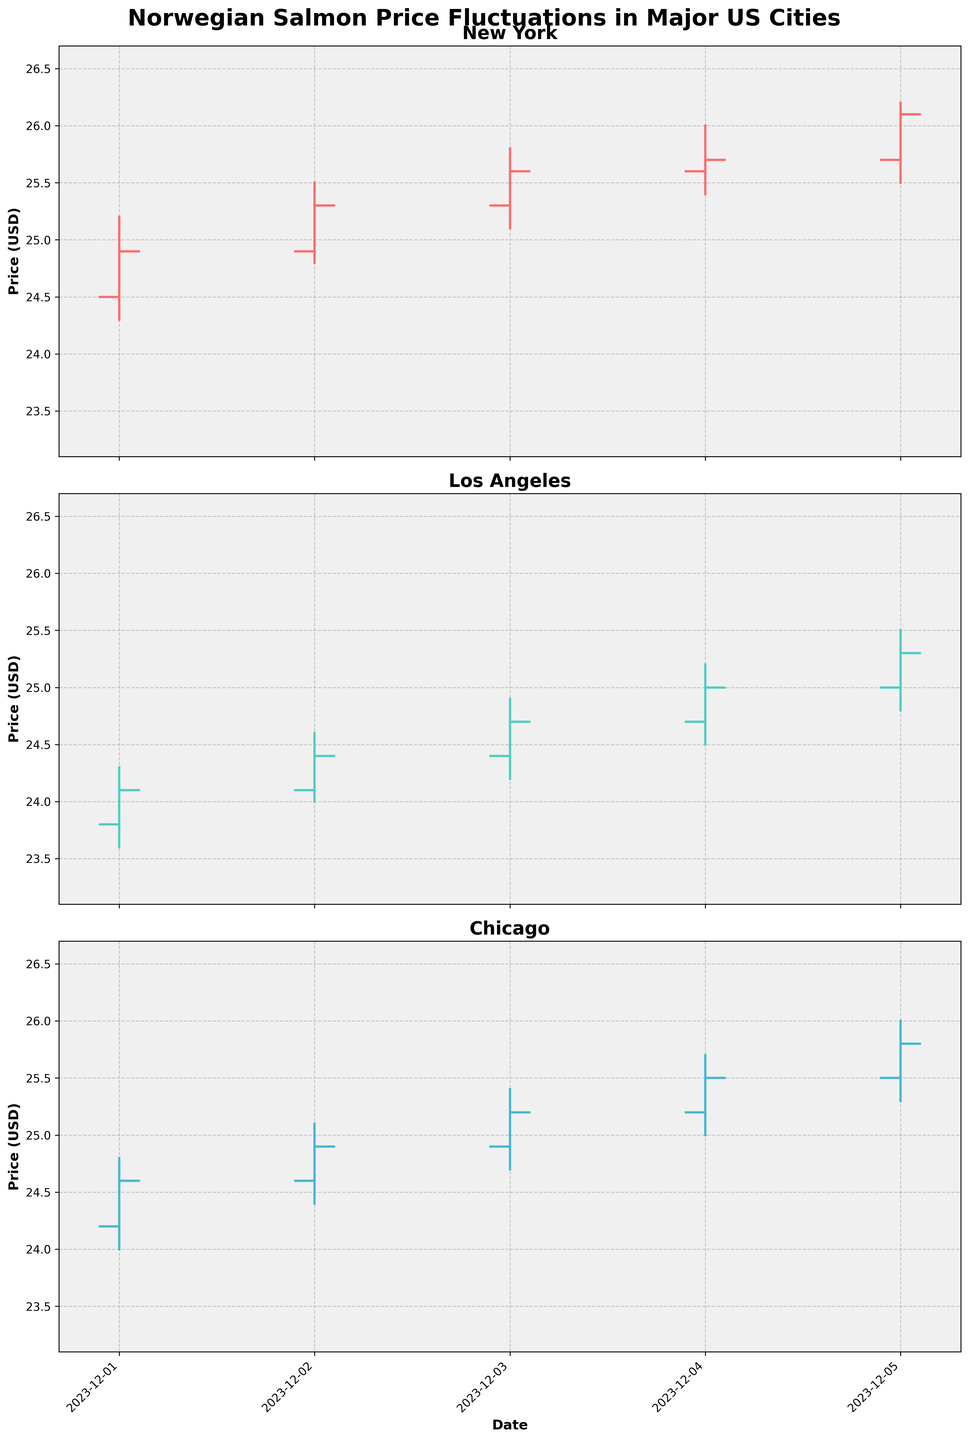What is the title of the chart? The title is located at the top of the figure and reads "Norwegian Salmon Price Fluctuations in Major US Cities".
Answer: Norwegian Salmon Price Fluctuations in Major US Cities Which city had the lowest opening price on December 1, 2023? By referring to the opening prices on December 1, 2023, for each city, New York had an opening price of 24.50, Los Angeles had an opening price of 23.80, and Chicago had an opening price of 24.20. The lowest opening price among these was in Los Angeles.
Answer: Los Angeles How many data points are there for each city? Count the number of days (from December 1 to December 5) for which we have data for each city. Each city's subplot has data for 5 days, so there are 5 data points per city.
Answer: 5 Which city had the greatest price fluctuation in December 2023? To determine the greatest price fluctuation, calculate the range (difference between the highest high and lowest low) for each city. New York had a range of (26.20 - 24.30) = 1.90, Los Angeles had a range of (25.50 - 23.60) = 1.90, and Chicago had a range of (26.00 - 24.00) = 2.00. Chicago had the greatest price fluctuation.
Answer: Chicago On which date did New York have the highest closing price? Check the closing prices for New York on each date. The highest closing price for New York was on December 5, 2023, with a closing price of 26.10.
Answer: December 5, 2023 What was the highest price recorded for Los Angeles in December 2023? The highest price recorded for Los Angeles, according to the 'High' column, was 25.50 on December 5, 2023.
Answer: 25.50 Comparing December 3, 2023, which city had the highest closing price? Check the closing prices on December 3, 2023, for each city: New York closed at 25.60, Los Angeles closed at 24.70, and Chicago closed at 25.20. New York had the highest closing price.
Answer: New York What was the average closing price for Chicago over these five days? Calculate the average closing price by summing Chicago's closing prices (24.60 + 24.90 + 25.20 + 25.50 + 25.80) and dividing by the number of days (5). (24.60 + 24.90 + 25.20 + 25.50 + 25.80) / 5 = 25.20.
Answer: 25.20 Between December 1 and December 5, 2023, which city showed a consistent increase in the closing prices? Examine the closing prices for each city over the five days. New York had closing prices (24.90, 25.30, 25.60, 25.70, 26.10), Los Angeles had (24.10, 24.40, 24.70, 25.00, 25.30), and Chicago had (24.60, 24.90, 25.20, 25.50, 25.80). All three cities showed an increase, but none were consistent every single day, so "none" is correct.
Answer: None 